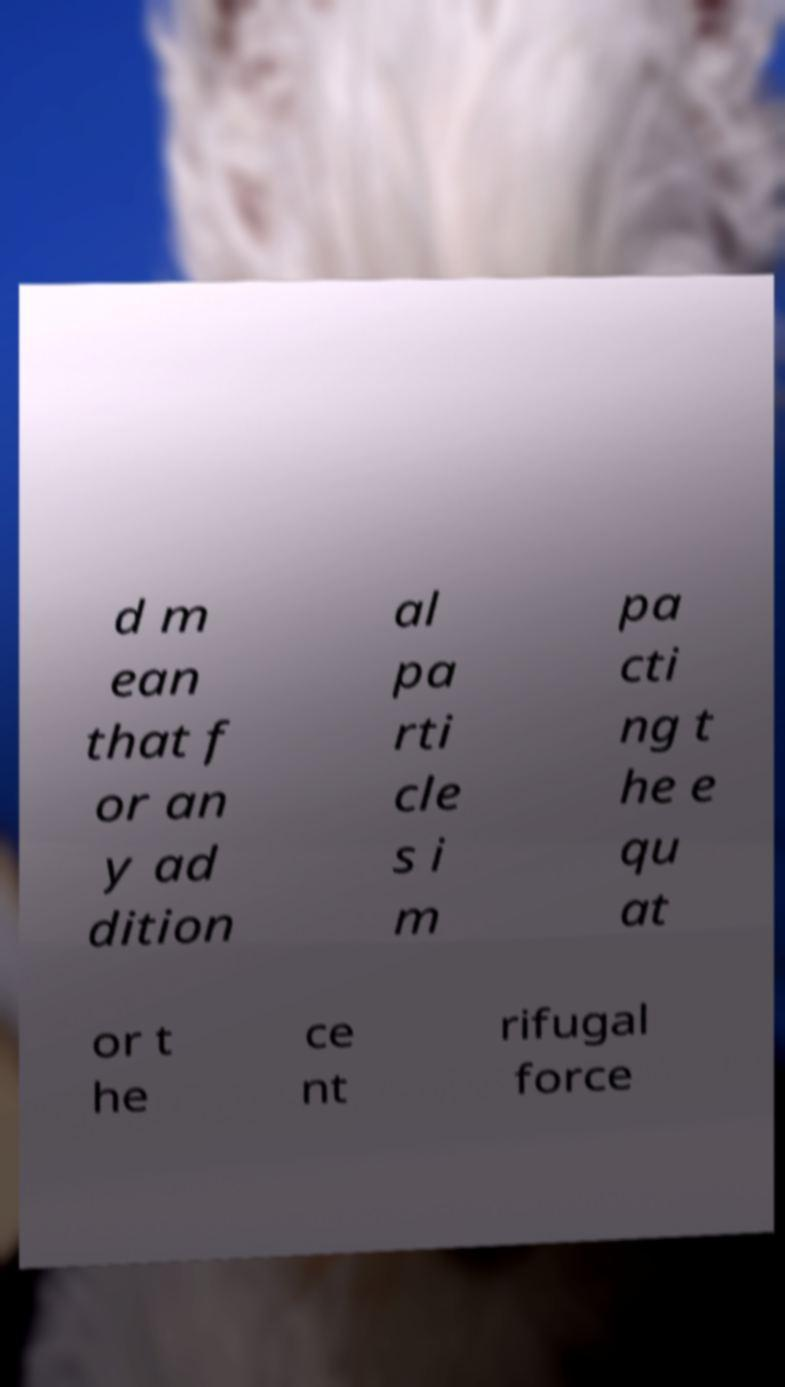What messages or text are displayed in this image? I need them in a readable, typed format. d m ean that f or an y ad dition al pa rti cle s i m pa cti ng t he e qu at or t he ce nt rifugal force 